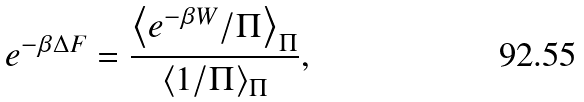Convert formula to latex. <formula><loc_0><loc_0><loc_500><loc_500>e ^ { - \beta \Delta F } = \frac { \left \langle e ^ { - \beta W } / \Pi \right \rangle _ { \Pi } } { \langle 1 / \Pi \rangle _ { \Pi } } ,</formula> 